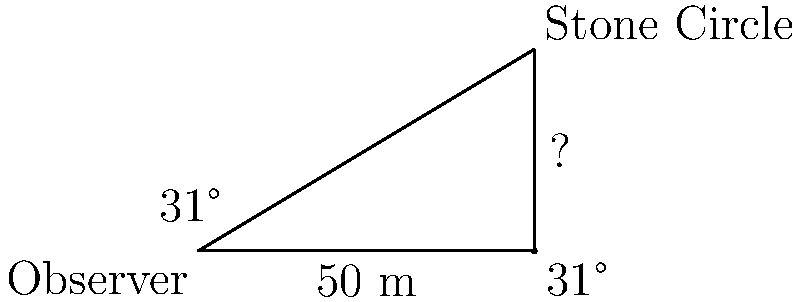You are observing an ancient Celtic stone circle from a distance. The angle of elevation to the top of the circle is 31°, and you are standing 50 meters away from the base of the circle. What is the height of the stone circle to the nearest meter? To solve this problem, we can use the tangent function from trigonometry. The tangent of an angle in a right triangle is the ratio of the opposite side to the adjacent side.

Let's break it down step-by-step:

1) We have a right triangle where:
   - The adjacent side is the distance from the observer to the base of the circle (50 m)
   - The opposite side is the height of the circle (what we're solving for)
   - The angle of elevation is 31°

2) The tangent formula is:
   $\tan(\theta) = \frac{\text{opposite}}{\text{adjacent}}$

3) Plugging in our known values:
   $\tan(31°) = \frac{\text{height}}{50}$

4) To solve for height, we multiply both sides by 50:
   $50 \cdot \tan(31°) = \text{height}$

5) Now we can calculate:
   $\text{height} = 50 \cdot \tan(31°)$
   $\text{height} = 50 \cdot 0.6009$ (using a calculator)
   $\text{height} = 30.045$ meters

6) Rounding to the nearest meter:
   $\text{height} \approx 30$ meters

Therefore, the height of the stone circle is approximately 30 meters.
Answer: 30 meters 